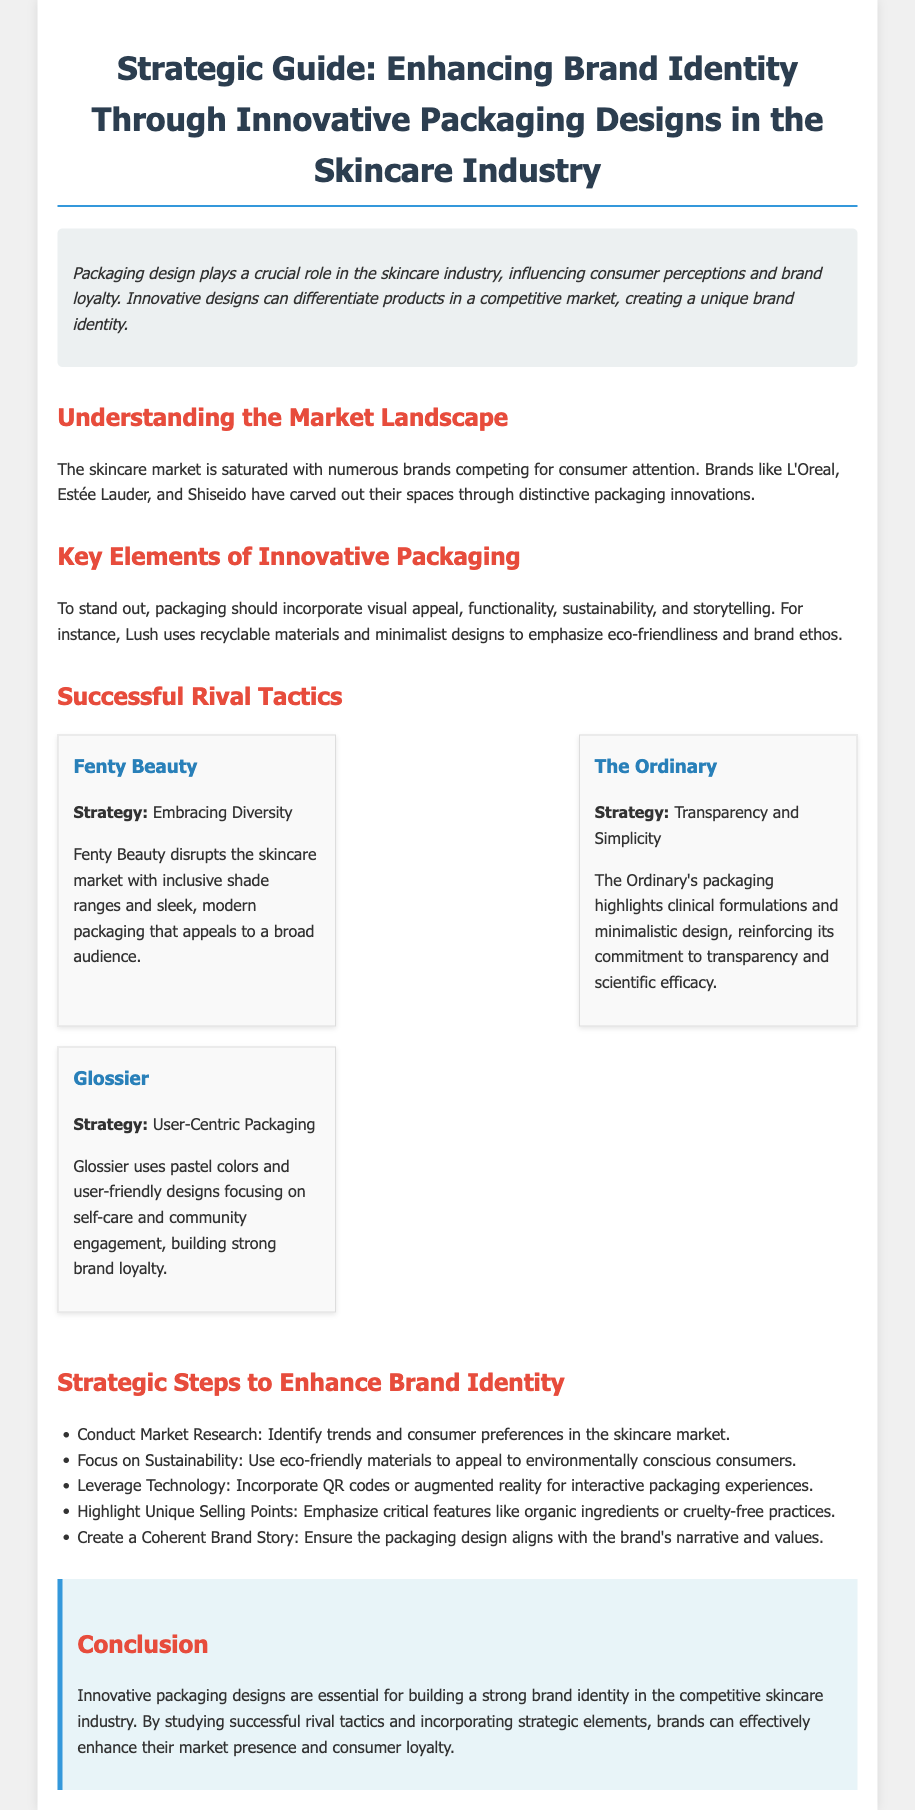What is the strategic guide about? The document provides a guide on enhancing brand identity through innovative packaging designs in the skincare industry.
Answer: Enhancing brand identity through innovative packaging designs in the skincare industry Which brands are mentioned as examples of distinct packaging innovations? The document mentions L'Oreal, Estée Lauder, and Shiseido as brands with distinctive packaging innovations.
Answer: L'Oreal, Estée Lauder, Shiseido What are the key elements of innovative packaging listed? The document lists visual appeal, functionality, sustainability, and storytelling as key elements of innovative packaging.
Answer: Visual appeal, functionality, sustainability, storytelling What packaging strategy does Fenty Beauty use? Fenty Beauty’s strategy focuses on embracing diversity through inclusive shade ranges and modern packaging.
Answer: Embracing Diversity Which brand emphasizes transparency and scientific efficacy? The Ordinary highlights transparency and scientific efficacy through its minimalistic design and clinical formulations.
Answer: The Ordinary What is one strategic step to enhance brand identity? The document mentions conducting market research as a strategic step to enhance brand identity.
Answer: Conduct Market Research What colors does Glossier use in its packaging? Glossier uses pastel colors in its user-friendly packaging designs.
Answer: Pastel colors What type of materials does Lush prioritize in its packaging? Lush prioritizes recyclable materials in its packaging to emphasize eco-friendliness.
Answer: Recyclable materials What should packaging design align with according to the document? Packaging design should align with the brand's narrative and values as mentioned in the document.
Answer: Brand's narrative and values 